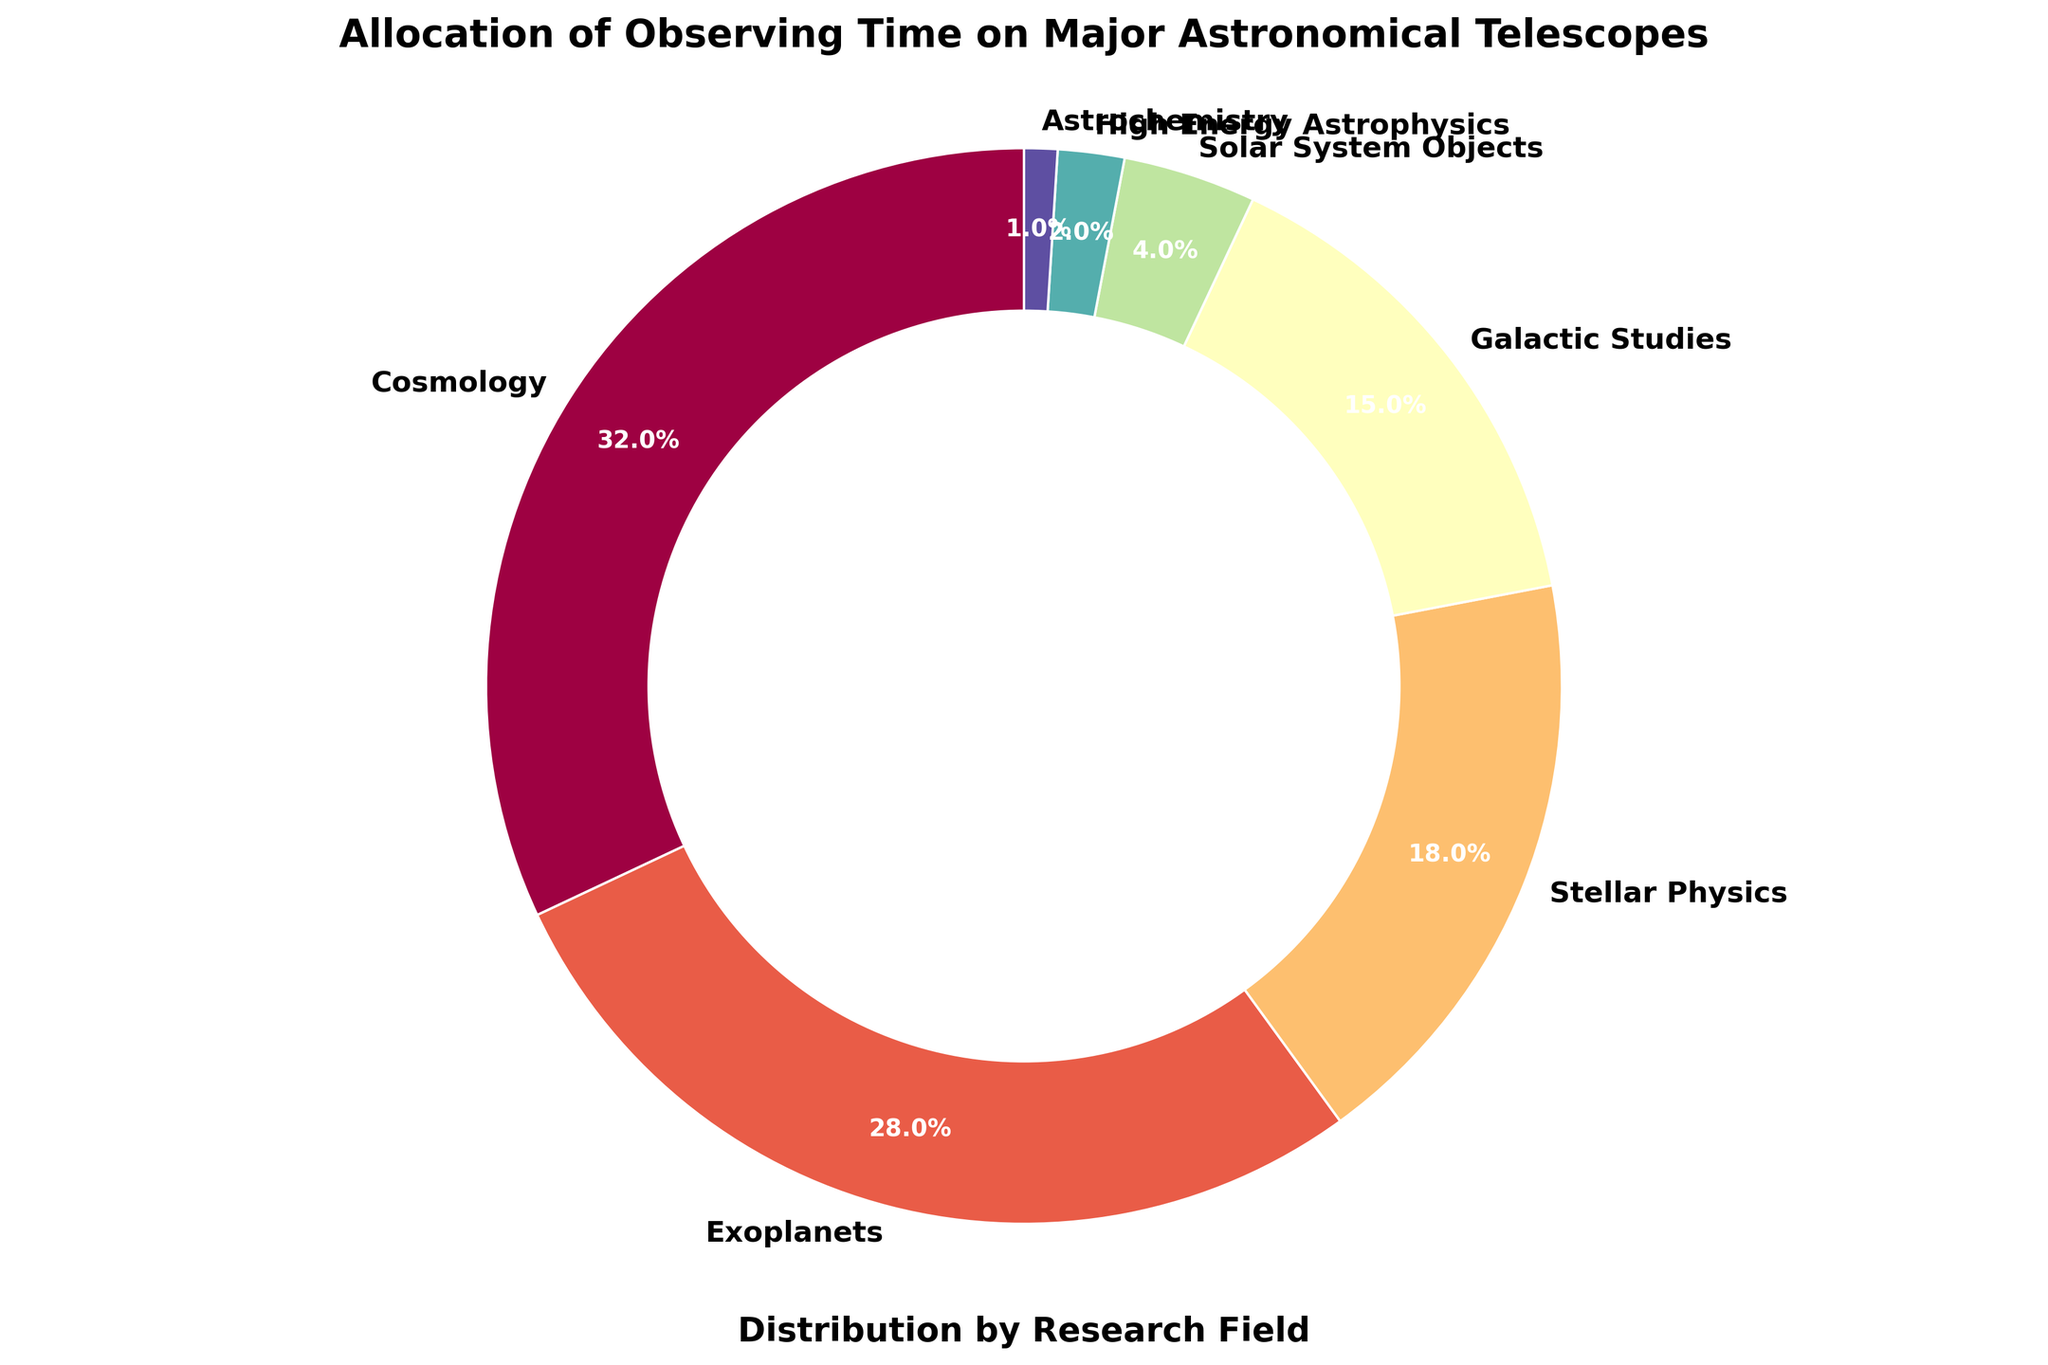What is the most allocated research field in the figure? The figure shows a pie chart with various research fields. The largest segment, which is colored prominently, represents cosmology with 32%.
Answer: Cosmology Which two research fields combined use the most observing time? The figure displays percentages for each research field. Adding Cosmology (32%) and Exoplanets (28%) gives 60%, which is the highest combined total in the chart.
Answer: Cosmology and Exoplanets Compare the allocation for Stellar Physics and Galactic Studies. What is the difference in percentage points? From the chart, Stellar Physics is allocated 18% and Galactic Studies 15%. The difference is 18% - 15% = 3%.
Answer: 3% What percentage of the observing time is allocated to research fields other than Cosmology, Exoplanets, and Stellar Physics? To find this, we sum the percentages of Galactic Studies (15%), Solar System Objects (4%), High Energy Astrophysics (2%), and Astrochemistry (1%). The total is 15% + 4% + 2% + 1% = 22%.
Answer: 22% Which field has the least allocation, and what is its percentage? The smallest segment in the pie chart, represented by a thin slice at the end, is for Astrochemistry with 1%.
Answer: Astrochemistry (1%) What is the total percentage of the top three allocated research fields? Adding the top three fields: Cosmology (32%), Exoplanets (28%), and Stellar Physics (18%) gives 32% + 28% + 18% = 78%.
Answer: 78% How much more time is allocated to Cosmology than to Solar System Objects? Cosmology is allocated 32%, while Solar System Objects receive 4%. The difference is 32% - 4% = 28%.
Answer: 28% If you combine the percentages of High Energy Astrophysics and Astrochemistry, what total does it contribute to the overall allocation? Adding High Energy Astrophysics (2%) and Astrochemistry (1%) gives 2% + 1% = 3%.
Answer: 3% How does the allocation for Exoplanets compare visually to the allocation for Galactic Studies? Exoplanets has a larger pie segment than Galactic Studies, implying a higher percentage. By comparison, Exoplanets is allocated 28% while Galactic Studies is 15%.
Answer: Exoplanets has a higher allocation by 13% What is the combined allocation percentage for fields related to objects within our galaxy (Stellar Physics, Galactic Studies, Solar System Objects)? Summing the percentages for Stellar Physics (18%), Galactic Studies (15%), and Solar System Objects (4%) gives 18% + 15% + 4% = 37%.
Answer: 37% 